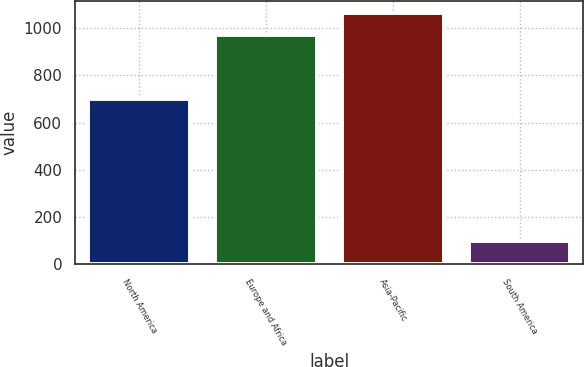<chart> <loc_0><loc_0><loc_500><loc_500><bar_chart><fcel>North America<fcel>Europe and Africa<fcel>Asia-Pacific<fcel>South America<nl><fcel>698<fcel>970<fcel>1062.9<fcel>97<nl></chart> 